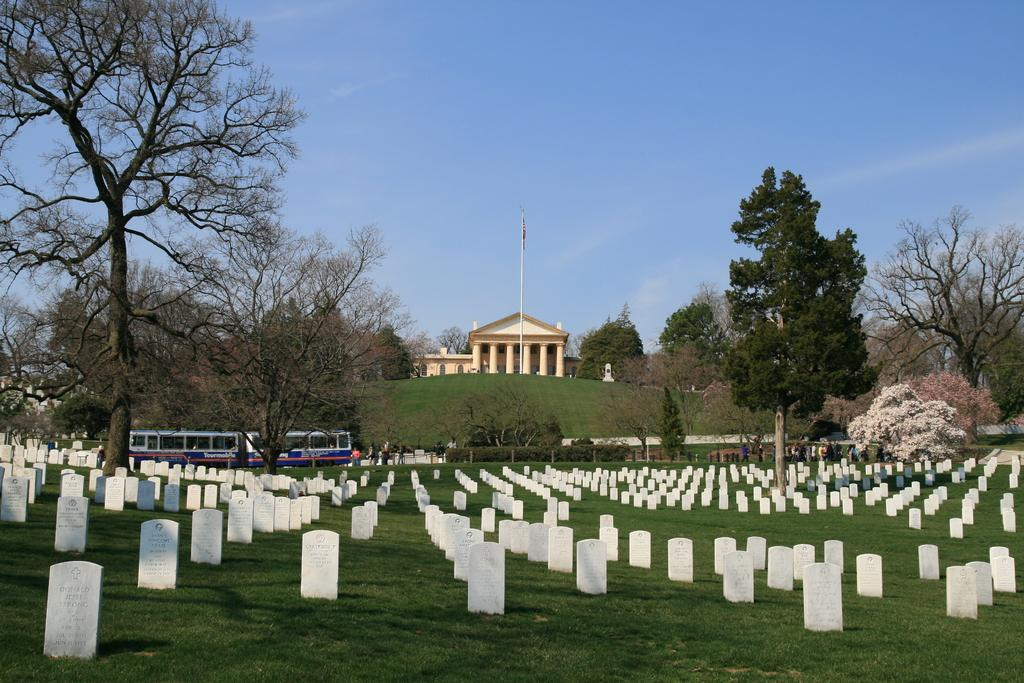What type of location is depicted in the image? There is a graveyard in the image. What else can be seen in the image besides the graveyard? There are groups of people, vehicles, trees, a hill, a building, and a pole visible in the image. What is visible in the background of the image? The sky is visible in the background of the image. What is the taste of the brass in the image? There is no brass present in the image, so it is not possible to determine its taste. 